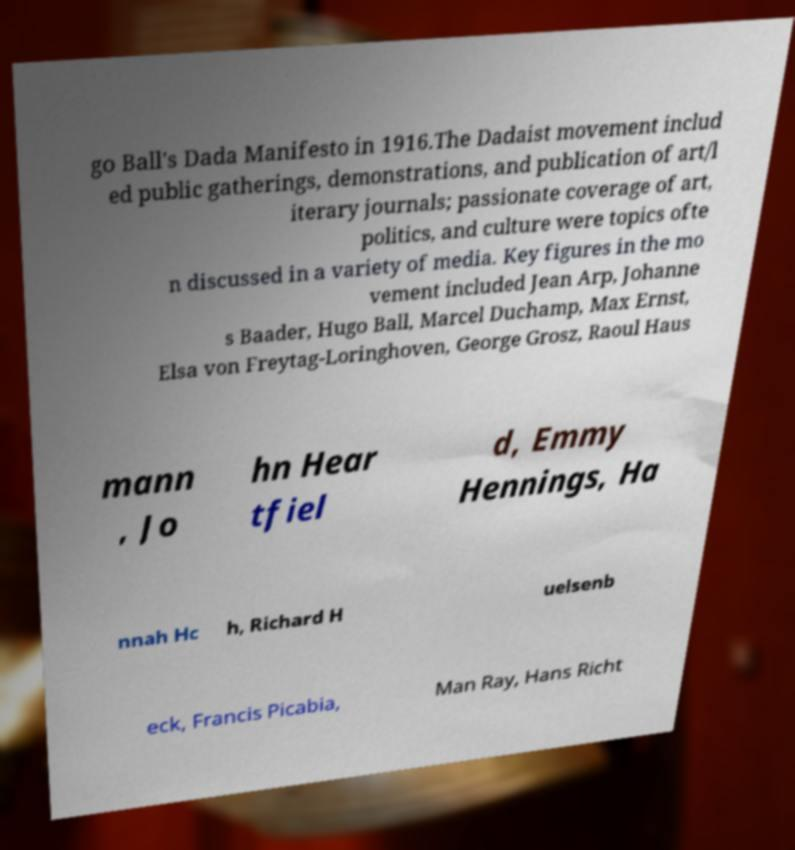Please identify and transcribe the text found in this image. go Ball's Dada Manifesto in 1916.The Dadaist movement includ ed public gatherings, demonstrations, and publication of art/l iterary journals; passionate coverage of art, politics, and culture were topics ofte n discussed in a variety of media. Key figures in the mo vement included Jean Arp, Johanne s Baader, Hugo Ball, Marcel Duchamp, Max Ernst, Elsa von Freytag-Loringhoven, George Grosz, Raoul Haus mann , Jo hn Hear tfiel d, Emmy Hennings, Ha nnah Hc h, Richard H uelsenb eck, Francis Picabia, Man Ray, Hans Richt 